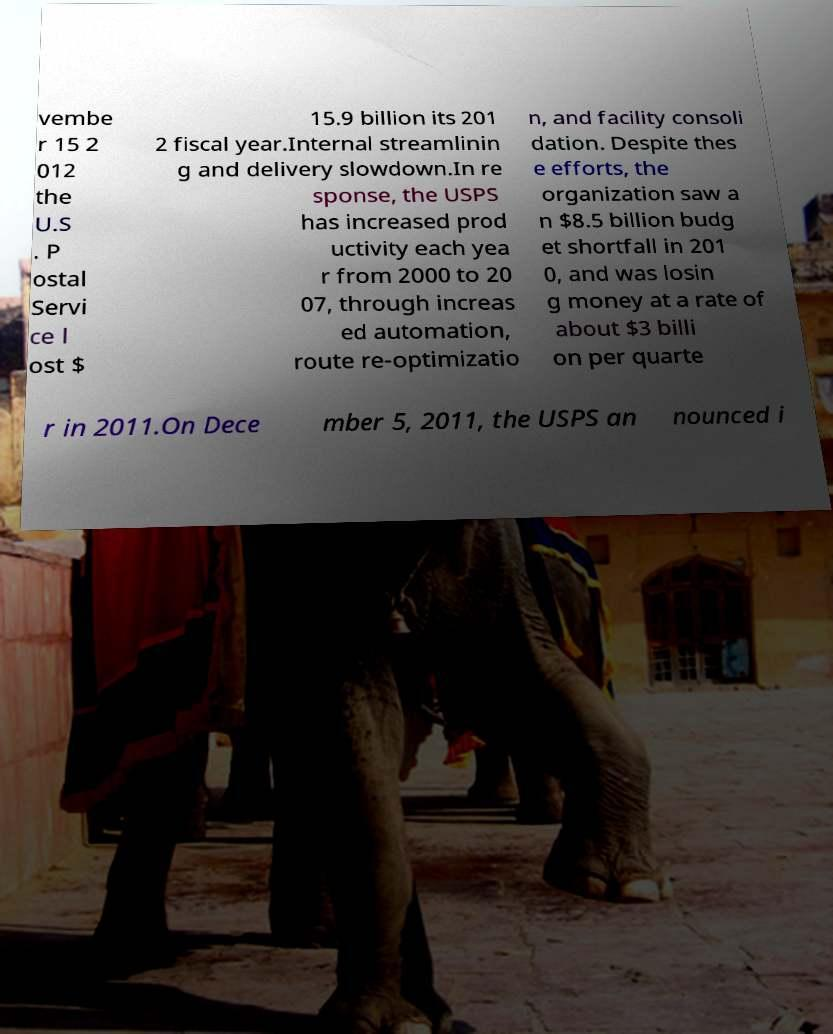Could you extract and type out the text from this image? vembe r 15 2 012 the U.S . P ostal Servi ce l ost $ 15.9 billion its 201 2 fiscal year.Internal streamlinin g and delivery slowdown.In re sponse, the USPS has increased prod uctivity each yea r from 2000 to 20 07, through increas ed automation, route re-optimizatio n, and facility consoli dation. Despite thes e efforts, the organization saw a n $8.5 billion budg et shortfall in 201 0, and was losin g money at a rate of about $3 billi on per quarte r in 2011.On Dece mber 5, 2011, the USPS an nounced i 